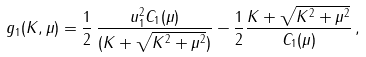<formula> <loc_0><loc_0><loc_500><loc_500>g _ { 1 } ( K , \mu ) = { \frac { 1 } { 2 } } \, { \frac { u _ { 1 } ^ { 2 } C _ { 1 } ( \mu ) } { ( K + \sqrt { K ^ { 2 } + \mu ^ { 2 } } ) } } - { \frac { 1 } { 2 } } { \frac { K + \sqrt { K ^ { 2 } + \mu ^ { 2 } } } { C _ { 1 } ( \mu ) } } \, ,</formula> 